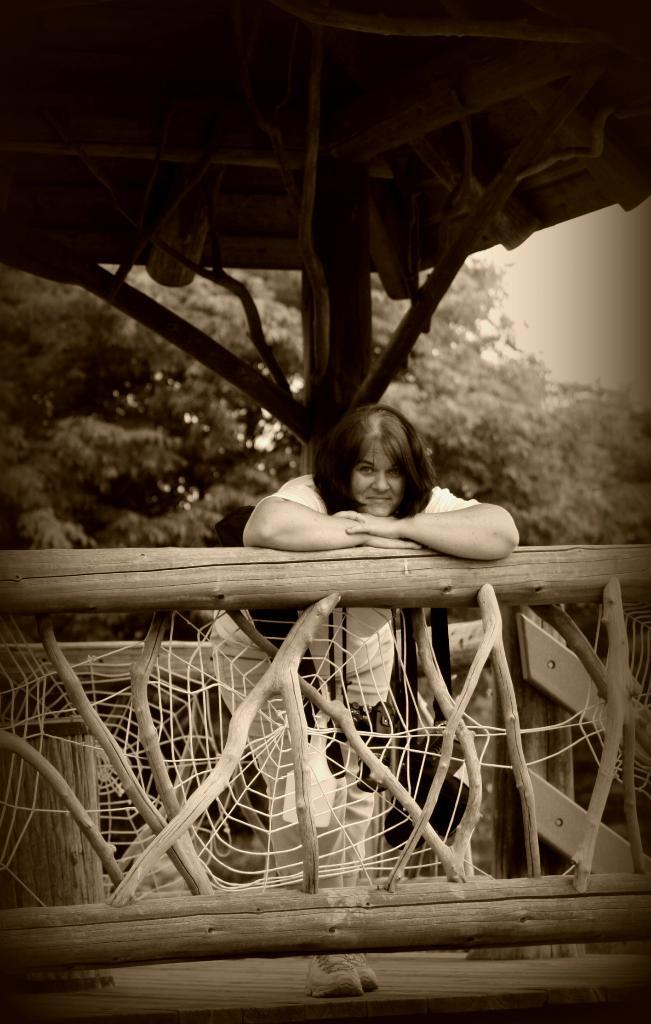Who is present in the image? There is a woman in the image. What is the woman standing under? The woman is standing under a wooden shed. What can be seen near the woman? There is a wooden railing near the woman. What is visible in the background of the image? There are trees visible behind the shed. What type of record is the snail listening to on the wooden railing? There is no snail or record present in the image. What kind of board is the woman using to balance on the wooden railing? The image does not show the woman using a board or balancing on the wooden railing. 